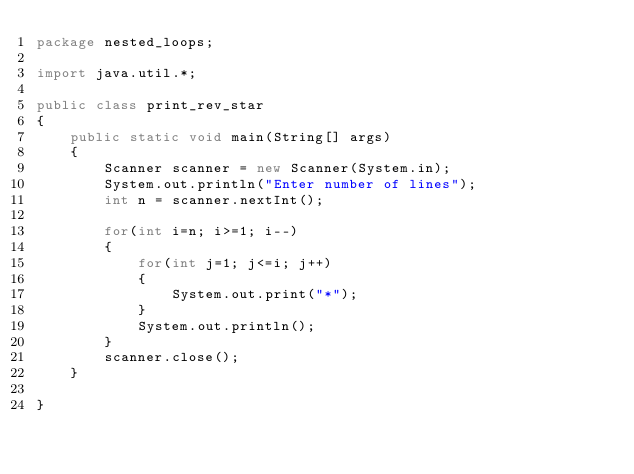<code> <loc_0><loc_0><loc_500><loc_500><_Java_>package nested_loops;

import java.util.*;

public class print_rev_star
{
    public static void main(String[] args)
    {
        Scanner scanner = new Scanner(System.in);
        System.out.println("Enter number of lines");
        int n = scanner.nextInt();
        
        for(int i=n; i>=1; i--)
        {
            for(int j=1; j<=i; j++)
            {
                System.out.print("*");
            }
            System.out.println();
        }
        scanner.close();
    }
    
}
</code> 